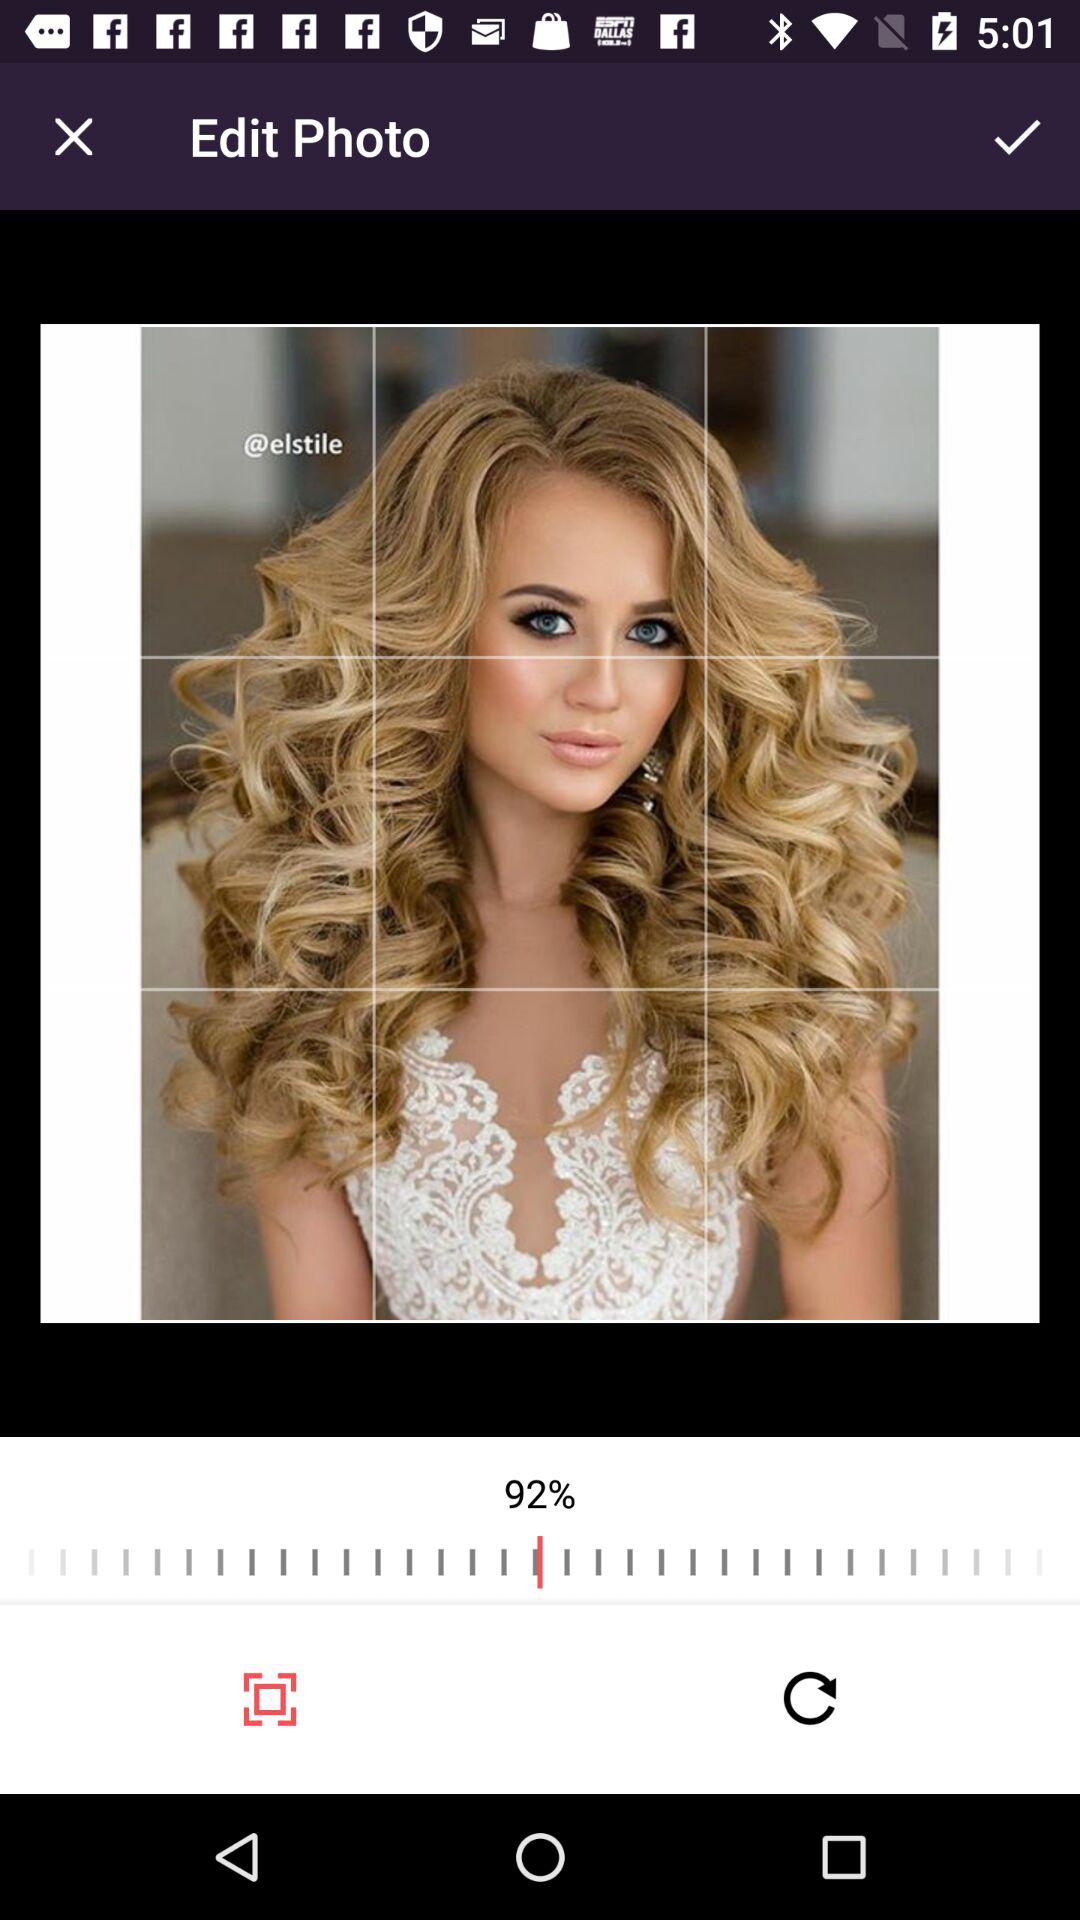What is the shown percentage? The shown percentage is 92. 